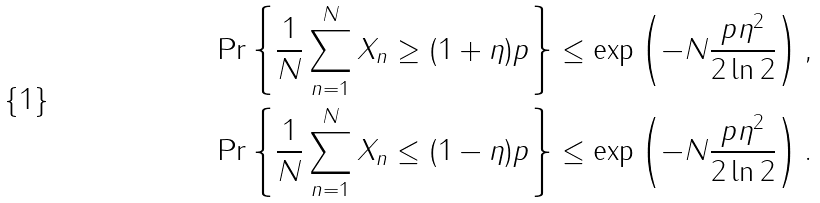Convert formula to latex. <formula><loc_0><loc_0><loc_500><loc_500>\Pr \left \{ \frac { 1 } { N } \sum _ { n = 1 } ^ { N } X _ { n } \geq ( 1 + \eta ) p \right \} & \leq \exp \left ( - N \frac { p \eta ^ { 2 } } { 2 \ln 2 } \right ) , \\ \Pr \left \{ \frac { 1 } { N } \sum _ { n = 1 } ^ { N } X _ { n } \leq ( 1 - \eta ) p \right \} & \leq \exp \left ( - N \frac { p \eta ^ { 2 } } { 2 \ln 2 } \right ) .</formula> 